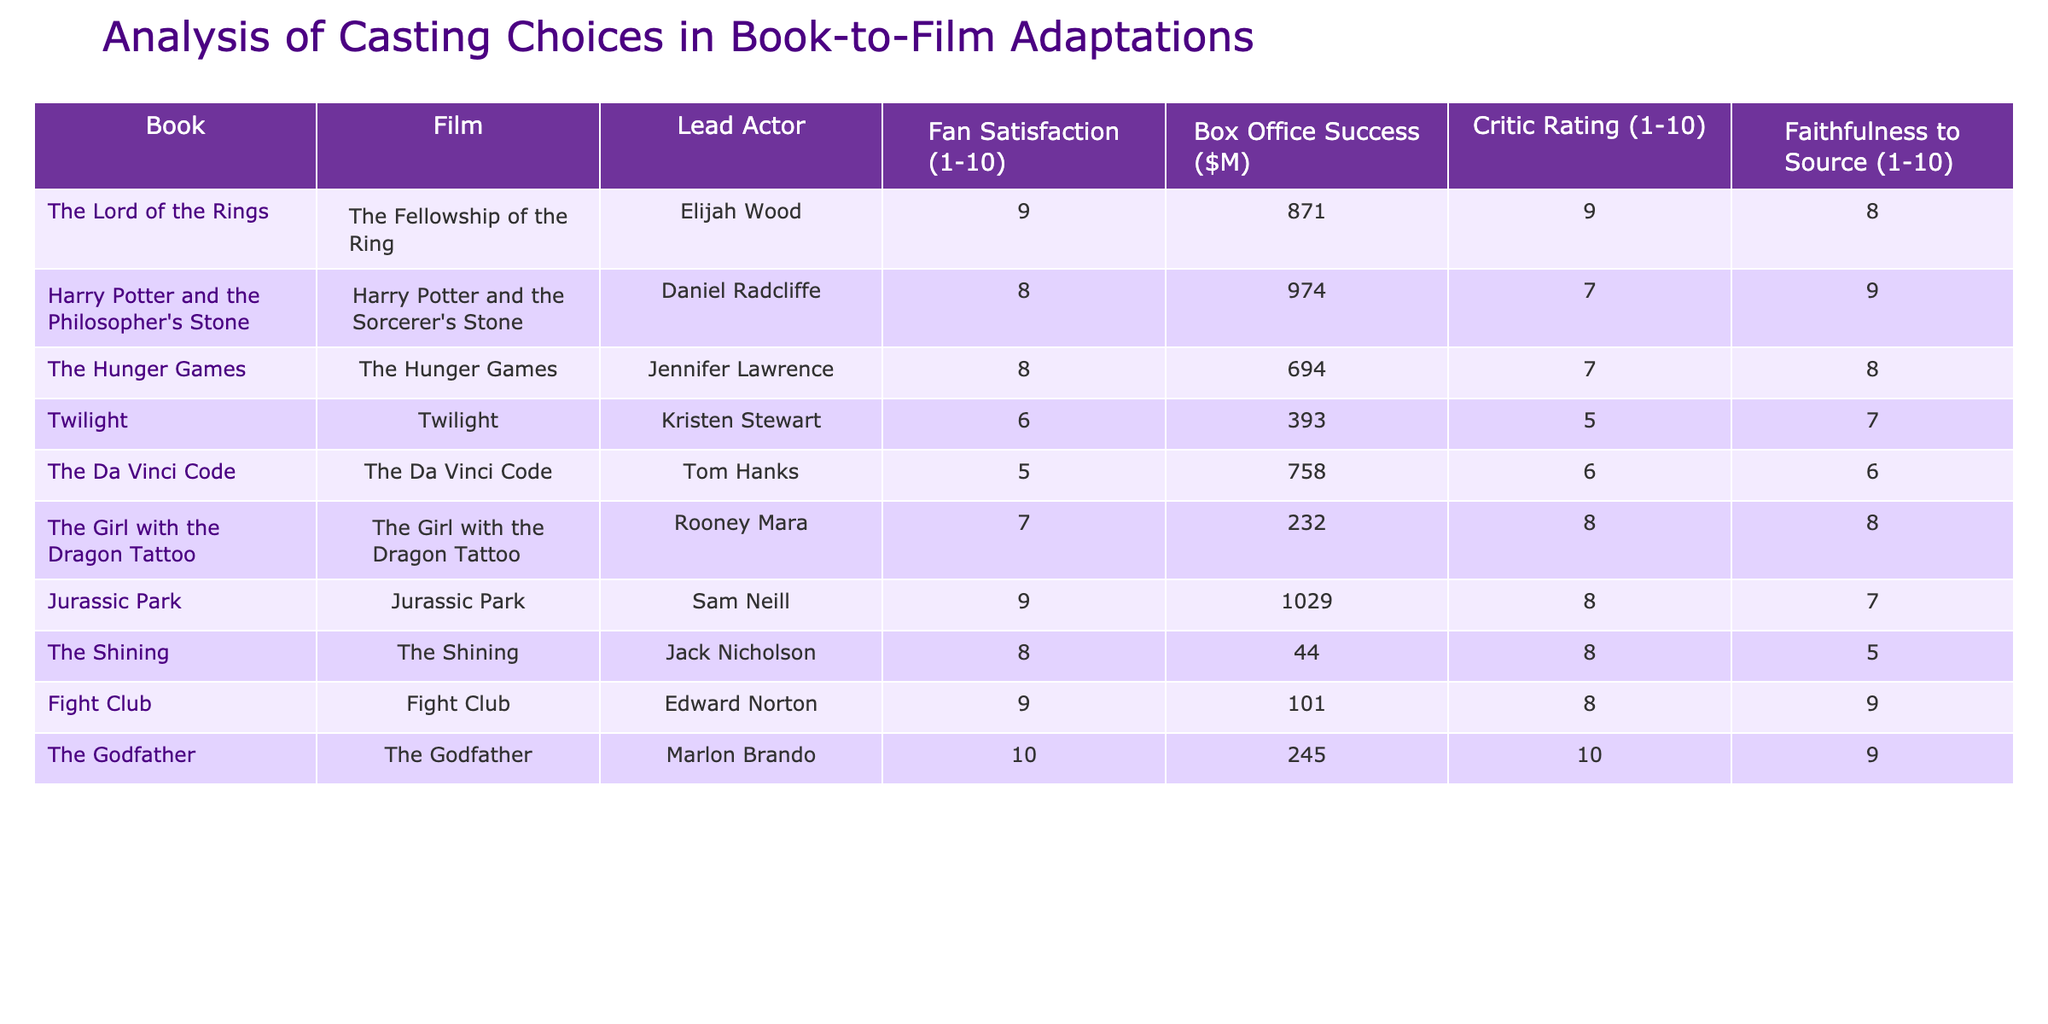What is the lead actor in "The Hunger Games"? According to the table, the lead actor for "The Hunger Games" is Jennifer Lawrence, which can be found in the row corresponding to that film.
Answer: Jennifer Lawrence Which film had the highest box office success? By looking at the "Box Office Success" column, "Jurassic Park" has the highest box office success at $1029 million. This is greater than the values for all other films listed.
Answer: Jurassic Park What is the average fan satisfaction rating for the films? To find the average fan satisfaction, add all the ratings (9 + 8 + 8 + 6 + 5 + 7 + 9 + 8 + 9 + 10 = 77) and divide by the number of films (10). The average fan satisfaction rating is 77/10 = 7.7.
Answer: 7.7 Did "The Da Vinci Code" receive a critic rating of 8 or higher? By checking the critic rating for "The Da Vinci Code," we find that it has a critic rating of 6, which is below 8. Thus, the answer is no.
Answer: No Which film has the lowest fan satisfaction and what is its score? Referring to the "Fan Satisfaction" column, "Twilight" has the lowest score with a fan satisfaction rating of 6. This information is in the corresponding row for "Twilight."
Answer: 6 